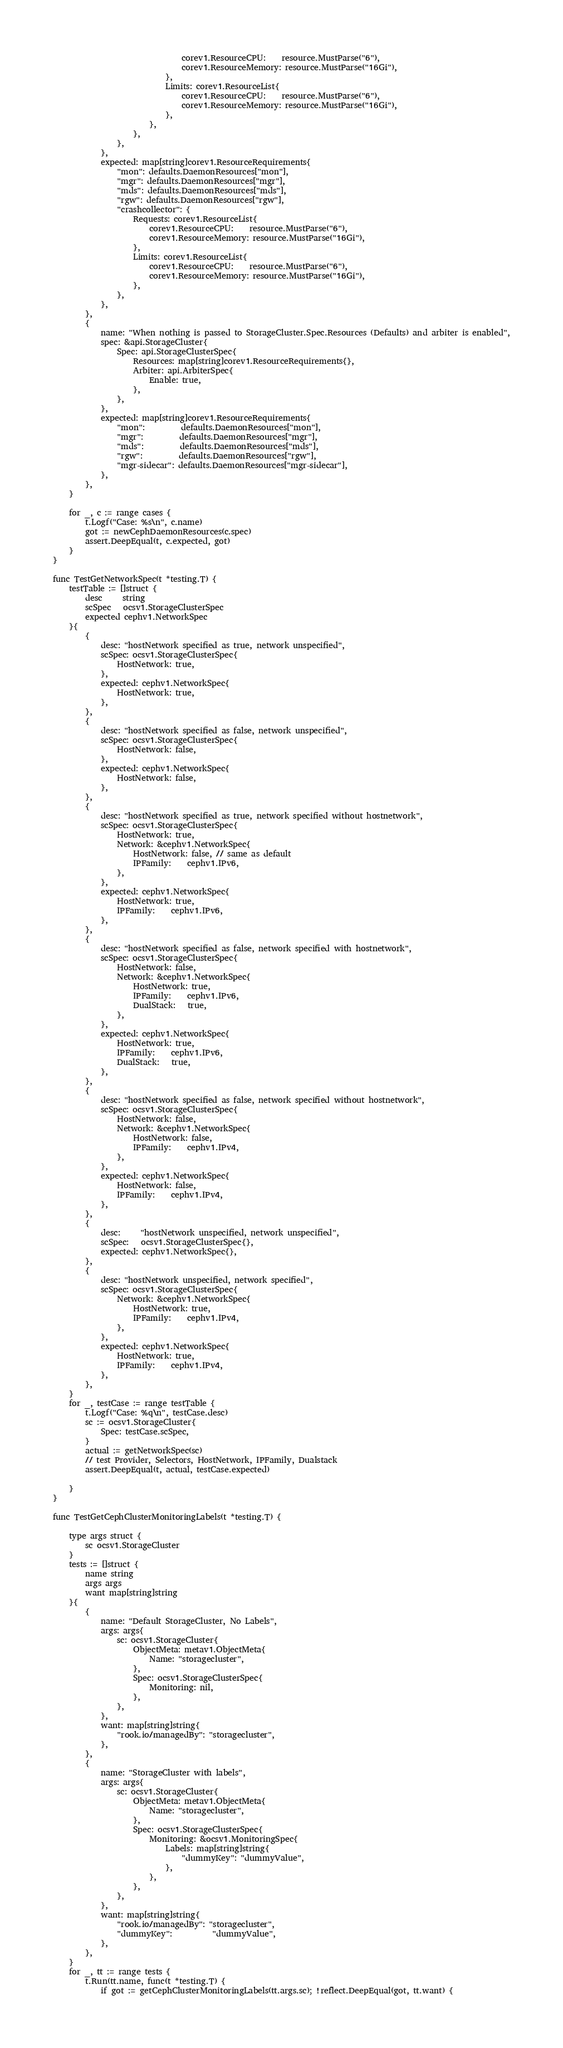<code> <loc_0><loc_0><loc_500><loc_500><_Go_>								corev1.ResourceCPU:    resource.MustParse("6"),
								corev1.ResourceMemory: resource.MustParse("16Gi"),
							},
							Limits: corev1.ResourceList{
								corev1.ResourceCPU:    resource.MustParse("6"),
								corev1.ResourceMemory: resource.MustParse("16Gi"),
							},
						},
					},
				},
			},
			expected: map[string]corev1.ResourceRequirements{
				"mon": defaults.DaemonResources["mon"],
				"mgr": defaults.DaemonResources["mgr"],
				"mds": defaults.DaemonResources["mds"],
				"rgw": defaults.DaemonResources["rgw"],
				"crashcollector": {
					Requests: corev1.ResourceList{
						corev1.ResourceCPU:    resource.MustParse("6"),
						corev1.ResourceMemory: resource.MustParse("16Gi"),
					},
					Limits: corev1.ResourceList{
						corev1.ResourceCPU:    resource.MustParse("6"),
						corev1.ResourceMemory: resource.MustParse("16Gi"),
					},
				},
			},
		},
		{
			name: "When nothing is passed to StorageCluster.Spec.Resources (Defaults) and arbiter is enabled",
			spec: &api.StorageCluster{
				Spec: api.StorageClusterSpec{
					Resources: map[string]corev1.ResourceRequirements{},
					Arbiter: api.ArbiterSpec{
						Enable: true,
					},
				},
			},
			expected: map[string]corev1.ResourceRequirements{
				"mon":         defaults.DaemonResources["mon"],
				"mgr":         defaults.DaemonResources["mgr"],
				"mds":         defaults.DaemonResources["mds"],
				"rgw":         defaults.DaemonResources["rgw"],
				"mgr-sidecar": defaults.DaemonResources["mgr-sidecar"],
			},
		},
	}

	for _, c := range cases {
		t.Logf("Case: %s\n", c.name)
		got := newCephDaemonResources(c.spec)
		assert.DeepEqual(t, c.expected, got)
	}
}

func TestGetNetworkSpec(t *testing.T) {
	testTable := []struct {
		desc     string
		scSpec   ocsv1.StorageClusterSpec
		expected cephv1.NetworkSpec
	}{
		{
			desc: "hostNetwork specified as true, network unspecified",
			scSpec: ocsv1.StorageClusterSpec{
				HostNetwork: true,
			},
			expected: cephv1.NetworkSpec{
				HostNetwork: true,
			},
		},
		{
			desc: "hostNetwork specified as false, network unspecified",
			scSpec: ocsv1.StorageClusterSpec{
				HostNetwork: false,
			},
			expected: cephv1.NetworkSpec{
				HostNetwork: false,
			},
		},
		{
			desc: "hostNetwork specified as true, network specified without hostnetwork",
			scSpec: ocsv1.StorageClusterSpec{
				HostNetwork: true,
				Network: &cephv1.NetworkSpec{
					HostNetwork: false, // same as default
					IPFamily:    cephv1.IPv6,
				},
			},
			expected: cephv1.NetworkSpec{
				HostNetwork: true,
				IPFamily:    cephv1.IPv6,
			},
		},
		{
			desc: "hostNetwork specified as false, network specified with hostnetwork",
			scSpec: ocsv1.StorageClusterSpec{
				HostNetwork: false,
				Network: &cephv1.NetworkSpec{
					HostNetwork: true,
					IPFamily:    cephv1.IPv6,
					DualStack:   true,
				},
			},
			expected: cephv1.NetworkSpec{
				HostNetwork: true,
				IPFamily:    cephv1.IPv6,
				DualStack:   true,
			},
		},
		{
			desc: "hostNetwork specified as false, network specified without hostnetwork",
			scSpec: ocsv1.StorageClusterSpec{
				HostNetwork: false,
				Network: &cephv1.NetworkSpec{
					HostNetwork: false,
					IPFamily:    cephv1.IPv4,
				},
			},
			expected: cephv1.NetworkSpec{
				HostNetwork: false,
				IPFamily:    cephv1.IPv4,
			},
		},
		{
			desc:     "hostNetwork unspecified, network unspecified",
			scSpec:   ocsv1.StorageClusterSpec{},
			expected: cephv1.NetworkSpec{},
		},
		{
			desc: "hostNetwork unspecified, network specified",
			scSpec: ocsv1.StorageClusterSpec{
				Network: &cephv1.NetworkSpec{
					HostNetwork: true,
					IPFamily:    cephv1.IPv4,
				},
			},
			expected: cephv1.NetworkSpec{
				HostNetwork: true,
				IPFamily:    cephv1.IPv4,
			},
		},
	}
	for _, testCase := range testTable {
		t.Logf("Case: %q\n", testCase.desc)
		sc := ocsv1.StorageCluster{
			Spec: testCase.scSpec,
		}
		actual := getNetworkSpec(sc)
		// test Provider, Selectors, HostNetwork, IPFamily, Dualstack
		assert.DeepEqual(t, actual, testCase.expected)

	}
}

func TestGetCephClusterMonitoringLabels(t *testing.T) {

	type args struct {
		sc ocsv1.StorageCluster
	}
	tests := []struct {
		name string
		args args
		want map[string]string
	}{
		{
			name: "Default StorageCluster, No Labels",
			args: args{
				sc: ocsv1.StorageCluster{
					ObjectMeta: metav1.ObjectMeta{
						Name: "storagecluster",
					},
					Spec: ocsv1.StorageClusterSpec{
						Monitoring: nil,
					},
				},
			},
			want: map[string]string{
				"rook.io/managedBy": "storagecluster",
			},
		},
		{
			name: "StorageCluster with labels",
			args: args{
				sc: ocsv1.StorageCluster{
					ObjectMeta: metav1.ObjectMeta{
						Name: "storagecluster",
					},
					Spec: ocsv1.StorageClusterSpec{
						Monitoring: &ocsv1.MonitoringSpec{
							Labels: map[string]string{
								"dummyKey": "dummyValue",
							},
						},
					},
				},
			},
			want: map[string]string{
				"rook.io/managedBy": "storagecluster",
				"dummyKey":          "dummyValue",
			},
		},
	}
	for _, tt := range tests {
		t.Run(tt.name, func(t *testing.T) {
			if got := getCephClusterMonitoringLabels(tt.args.sc); !reflect.DeepEqual(got, tt.want) {</code> 